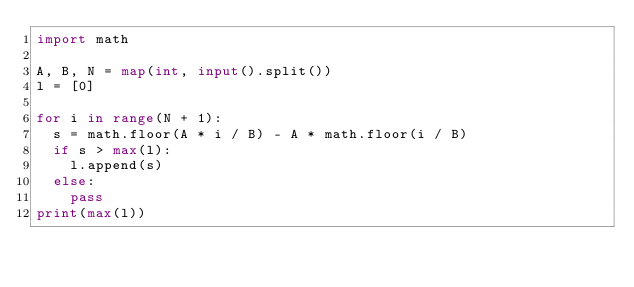Convert code to text. <code><loc_0><loc_0><loc_500><loc_500><_Python_>import math

A, B, N = map(int, input().split())
l = [0]

for i in range(N + 1):
  s = math.floor(A * i / B) - A * math.floor(i / B)
  if s > max(l):
    l.append(s)
  else:
    pass
print(max(l))</code> 